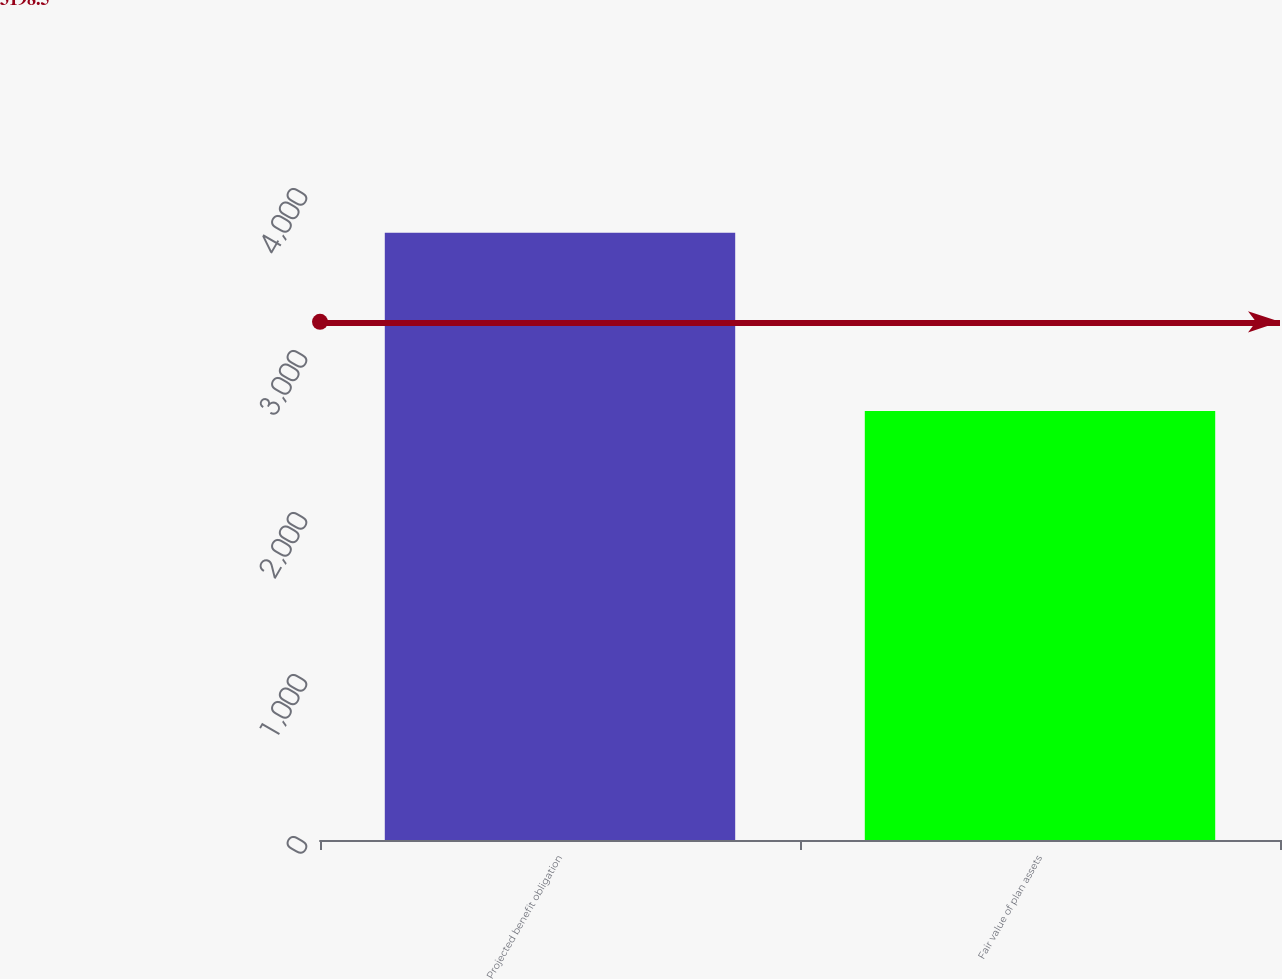<chart> <loc_0><loc_0><loc_500><loc_500><bar_chart><fcel>Projected benefit obligation<fcel>Fair value of plan assets<nl><fcel>3749<fcel>2648<nl></chart> 